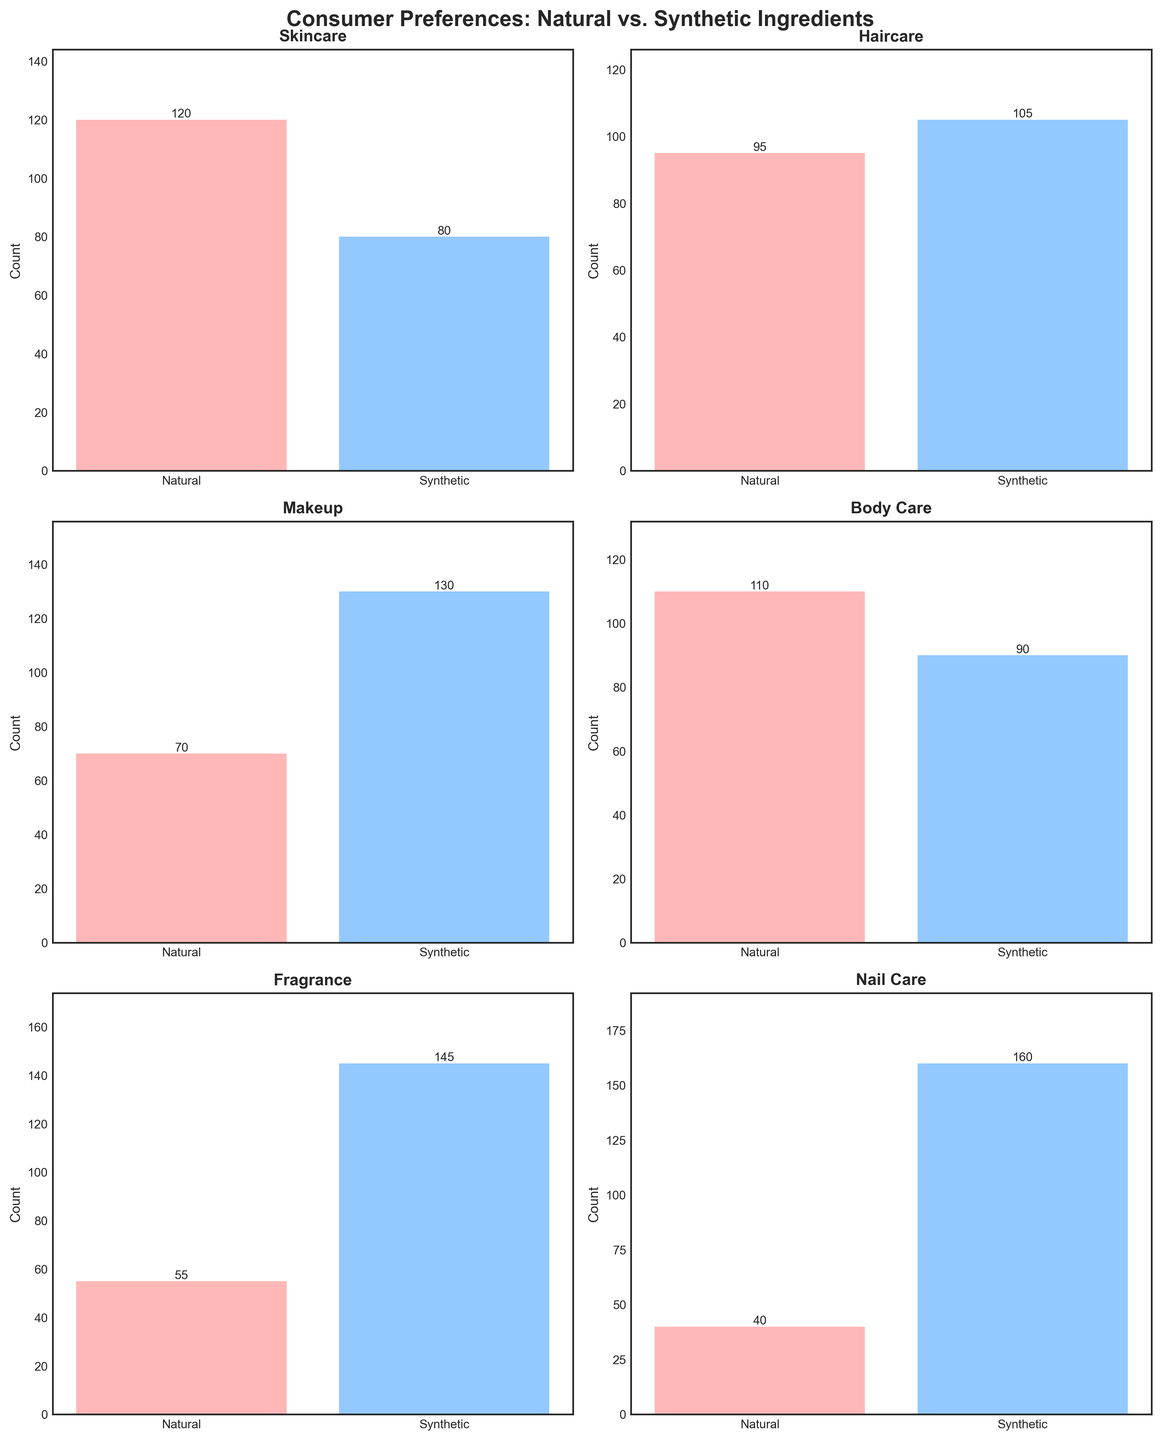What is the title of the figure? The title is usually found at the top of the figure. It provides an overview of what the figure represents.
Answer: Consumer Preferences: Natural vs. Synthetic Ingredients Which product category shows the highest count for synthetic preferences? Look at each subplot and identify the highest bar representing synthetic preferences. Compare these values across all categories.
Answer: Nail Care Which product category shows the smallest difference between natural and synthetic preferences? Calculate the difference between the counts for natural and synthetic preferences for each category and find the smallest difference.
Answer: Body Care How many people prefer natural ingredients in the Fragrance category? Look at the Fragrance subplot and identify the height of the bar representing natural preferences.
Answer: 55 Which product category has the most balanced preference for natural vs. synthetic ingredients? Compare the heights of bars in each subplot. Categories where the bars are closest in height represent the most balanced preferences. Examine these comparisons across all categories.
Answer: Body Care What is the total count of preferences for Haircare? Sum the counts for both natural and synthetic preferences in the Haircare category from its subplot.
Answer: 200 Compare the natural preferences for Skincare and Haircare. Which category has more natural preferences? Look at the Skincare and Haircare subplots and compare the heights of their natural preference bars.
Answer: Skincare In which product category do synthetic ingredients have the highest preference compared to natural ingredients? Calculate the difference between synthetic and natural preferences for each category and identify the category with the largest difference.
Answer: Nail Care How does the preference for natural ingredients in Makeup compare to that in Body Care? Look at the Makeup and Body Care subplots, and compare the heights of the natural preference bars.
Answer: Body Care has more natural preferences What is the total number of people who prefer synthetic ingredients across all categories? Sum the synthetic preference counts from each subplot to get the total.
Answer: 710 